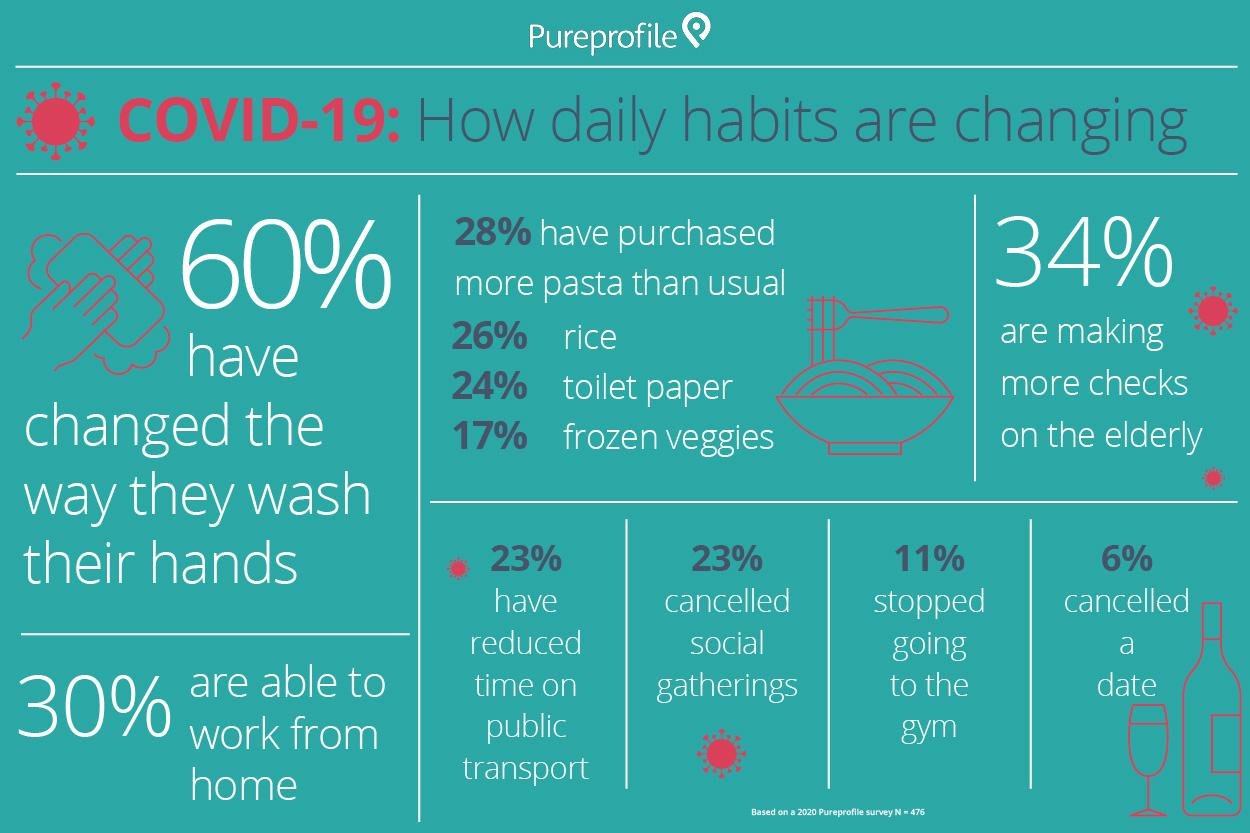Specify some key components in this picture. According to a survey, 23% of people cancelled social gatherings or reduced their time on public transport due to the COVID-19 pandemic. The majority of people have purchased more of a particular food item other than pasta than in the past. This item is not pasta. Pasta has been purchased by the majority of individuals at an increased rate compared to usual purchases. According to recent data, approximately 30% of people are working remotely. 